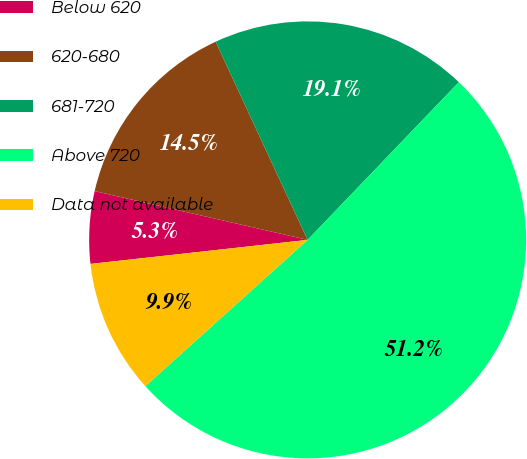<chart> <loc_0><loc_0><loc_500><loc_500><pie_chart><fcel>Below 620<fcel>620-680<fcel>681-720<fcel>Above 720<fcel>Data not available<nl><fcel>5.34%<fcel>14.5%<fcel>19.08%<fcel>51.16%<fcel>9.92%<nl></chart> 